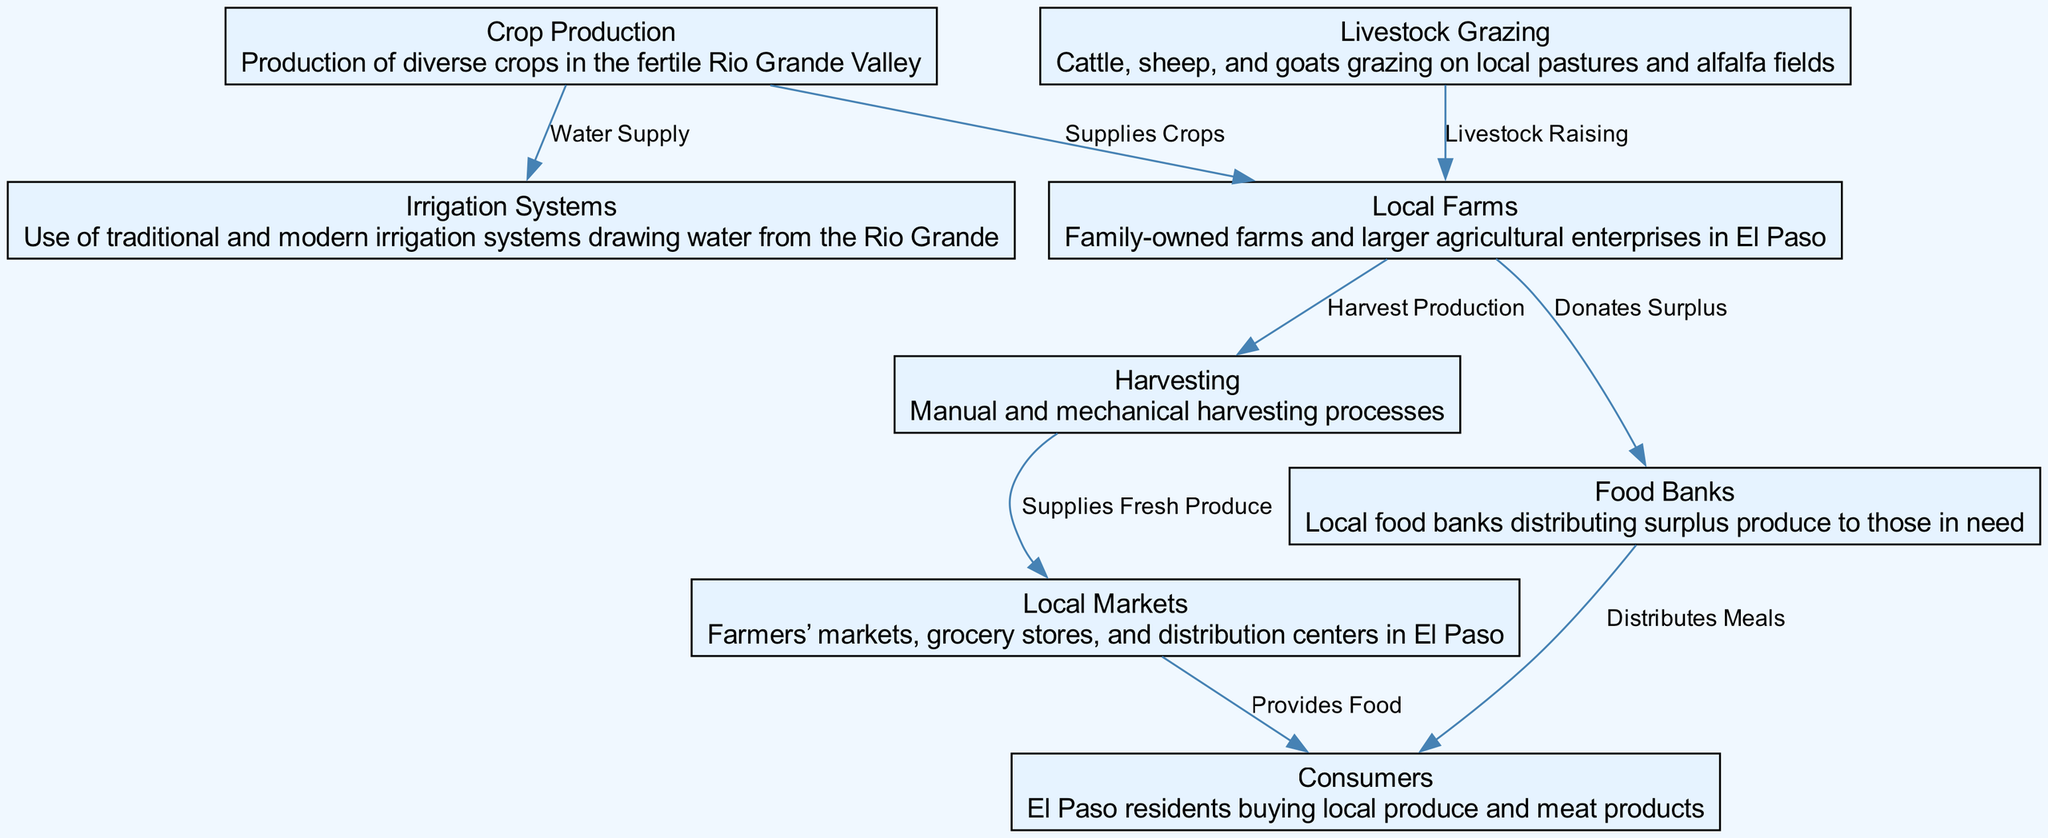What is the first node in the food chain? The first node in the food chain is "Crop Production," as it represents the initial step in the agriculture process where diverse crops are produced.
Answer: Crop Production How many nodes are in the food chain? By counting the nodes listed in the diagram, there are a total of eight nodes that represent different stages of the food chain.
Answer: Eight What role do irrigation systems play in crop production? Irrigation systems provide the necessary water supply to support crop production, drawing water from the Rio Grande to sustain farming activities.
Answer: Water Supply Which node is responsible for manual and mechanical harvesting? The node "Harvesting" is responsible for the processes involved in manually and mechanically collecting crops from local farms.
Answer: Harvesting What do local farms donate to food banks? Local farms donate surplus produce to food banks, which helps to distribute food to those in need within the community.
Answer: Surplus How do consumers obtain food from local markets? Consumers obtain food from local markets as these markets provide fresh produce and meat products sourced from local farms.
Answer: Provides Food What type of livestock grazes on local pastures according to the diagram? The diagram states that cattle, sheep, and goats are the types of livestock that graze on local pastures and alfalfa fields in El Paso.
Answer: Cattle, sheep, goats What is the connection between food banks and consumers? The connection is that food banks distribute meals to consumers, particularly to those in need, utilizing the surplus donated by local farms.
Answer: Distributes Meals What is the last step in the food chain before consumers? The last step before consumers is the "Local Markets," which serve as the point where food is provided for consumer purchase.
Answer: Local Markets 